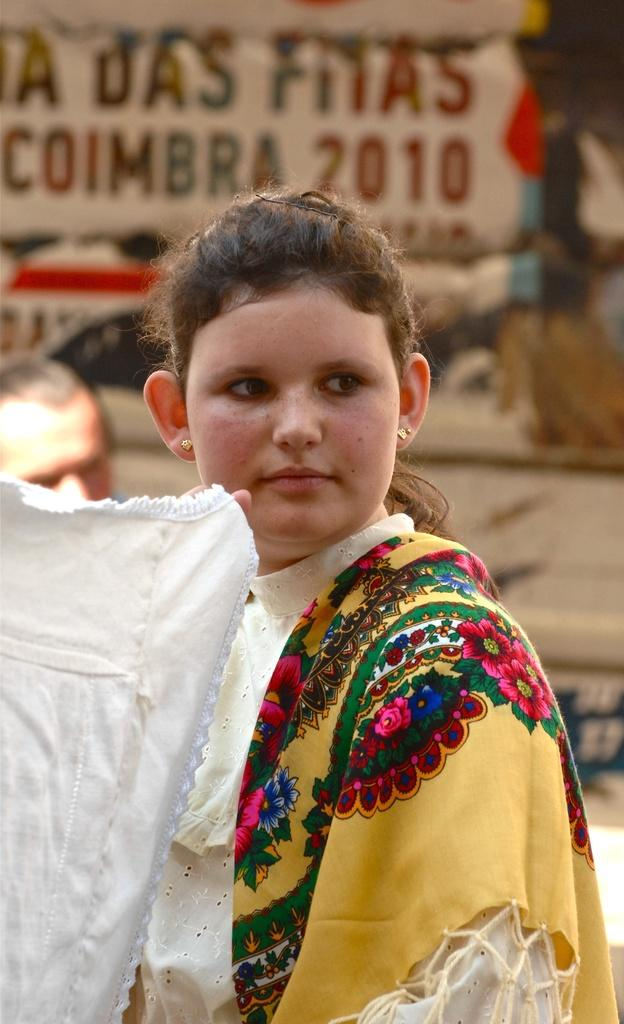Who is present in the image? There is a woman in the image. What is the woman wearing? The woman is wearing a scarf. What is the woman holding in the image? The woman is holding a white cloth. What can be seen in the background of the image? There is something written on a board in the background. Can you read the writing on the board? The writing on the board is blurred, so it cannot be read. What type of bean is being cooked in the oven in the image? There is no bean or oven present in the image. How many quinces are on the table in the image? There are no quinces or table present in the image. 